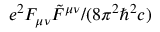Convert formula to latex. <formula><loc_0><loc_0><loc_500><loc_500>e ^ { 2 } F _ { \mu \nu } \tilde { F } ^ { \mu \nu } / ( 8 \pi ^ { 2 } \hbar { ^ } { 2 } c )</formula> 